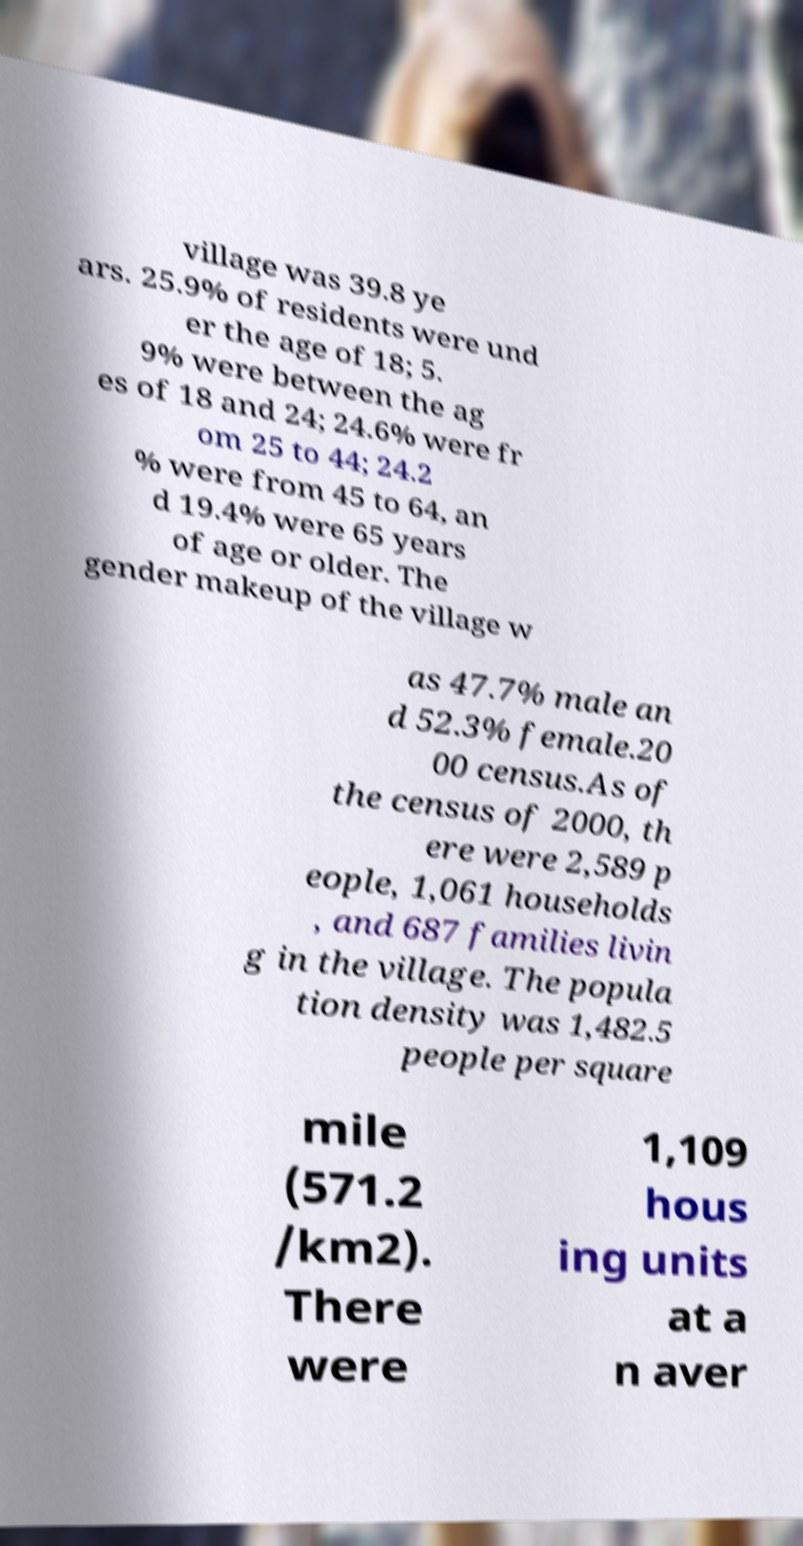Could you assist in decoding the text presented in this image and type it out clearly? village was 39.8 ye ars. 25.9% of residents were und er the age of 18; 5. 9% were between the ag es of 18 and 24; 24.6% were fr om 25 to 44; 24.2 % were from 45 to 64, an d 19.4% were 65 years of age or older. The gender makeup of the village w as 47.7% male an d 52.3% female.20 00 census.As of the census of 2000, th ere were 2,589 p eople, 1,061 households , and 687 families livin g in the village. The popula tion density was 1,482.5 people per square mile (571.2 /km2). There were 1,109 hous ing units at a n aver 